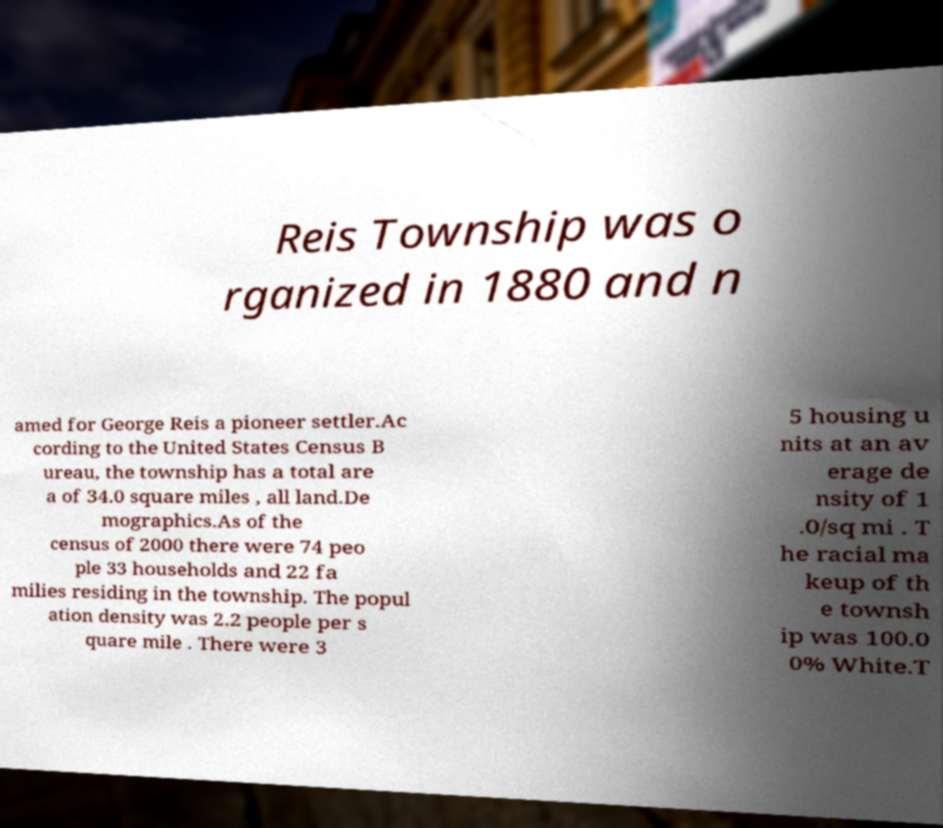Can you accurately transcribe the text from the provided image for me? Reis Township was o rganized in 1880 and n amed for George Reis a pioneer settler.Ac cording to the United States Census B ureau, the township has a total are a of 34.0 square miles , all land.De mographics.As of the census of 2000 there were 74 peo ple 33 households and 22 fa milies residing in the township. The popul ation density was 2.2 people per s quare mile . There were 3 5 housing u nits at an av erage de nsity of 1 .0/sq mi . T he racial ma keup of th e townsh ip was 100.0 0% White.T 